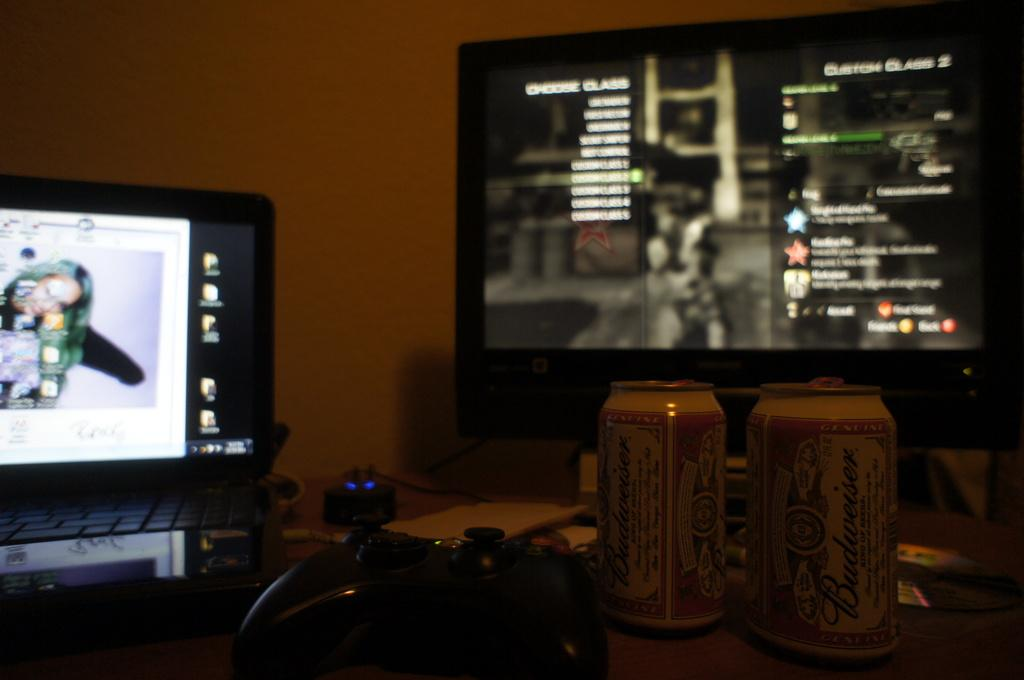Provide a one-sentence caption for the provided image. A video game is shown at a selection screen displaying Custom Class 2. 